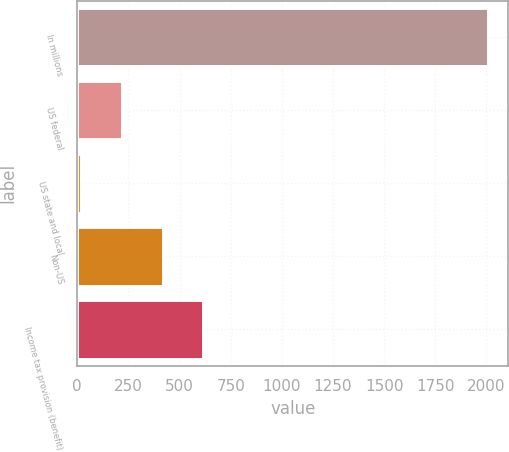Convert chart to OTSL. <chart><loc_0><loc_0><loc_500><loc_500><bar_chart><fcel>In millions<fcel>US federal<fcel>US state and local<fcel>Non-US<fcel>Income tax provision (benefit)<nl><fcel>2007<fcel>218.7<fcel>20<fcel>417.4<fcel>616.1<nl></chart> 